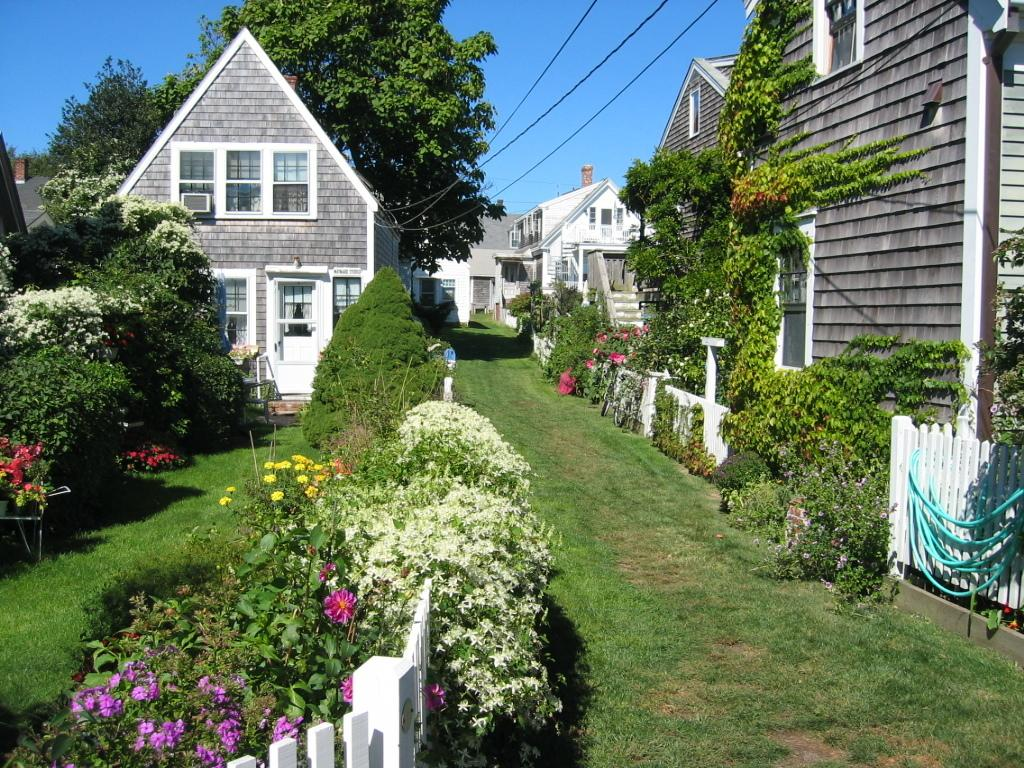What type of plants can be seen in the image? There are plants with flowers in the image. What type of vegetation is present on the ground? There is grass in the image. What type of barrier can be seen in the image? There is a fence in the image. What type of structures are visible in the image? There are houses in the image. What type of tall vegetation is present in the image? There are trees in the image. What type of man-made structures can be seen in the image? There are cables in the image. What can be seen in the background of the image? The sky is visible in the background of the image. Can you tell me how many grapes are hanging from the fence in the image? There are no grapes present in the image; it features plants with flowers, grass, a fence, houses, trees, cables, and a visible sky. What type of bun is sitting on the roof of the house in the image? There is no bun present on the roof of the house in the image. 